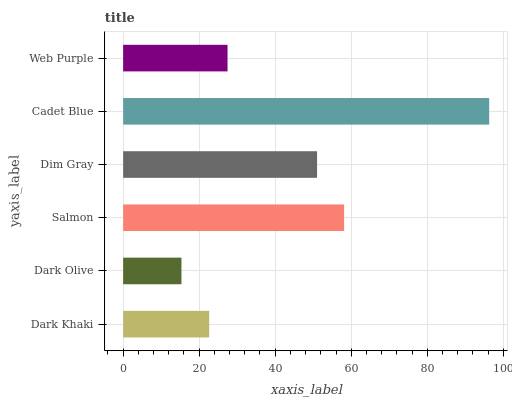Is Dark Olive the minimum?
Answer yes or no. Yes. Is Cadet Blue the maximum?
Answer yes or no. Yes. Is Salmon the minimum?
Answer yes or no. No. Is Salmon the maximum?
Answer yes or no. No. Is Salmon greater than Dark Olive?
Answer yes or no. Yes. Is Dark Olive less than Salmon?
Answer yes or no. Yes. Is Dark Olive greater than Salmon?
Answer yes or no. No. Is Salmon less than Dark Olive?
Answer yes or no. No. Is Dim Gray the high median?
Answer yes or no. Yes. Is Web Purple the low median?
Answer yes or no. Yes. Is Cadet Blue the high median?
Answer yes or no. No. Is Salmon the low median?
Answer yes or no. No. 